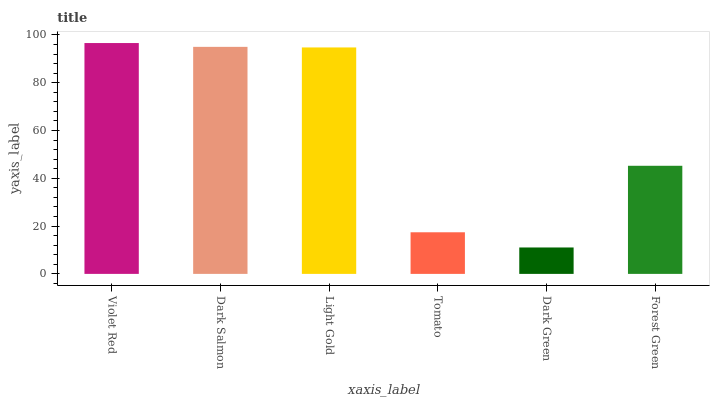Is Dark Green the minimum?
Answer yes or no. Yes. Is Violet Red the maximum?
Answer yes or no. Yes. Is Dark Salmon the minimum?
Answer yes or no. No. Is Dark Salmon the maximum?
Answer yes or no. No. Is Violet Red greater than Dark Salmon?
Answer yes or no. Yes. Is Dark Salmon less than Violet Red?
Answer yes or no. Yes. Is Dark Salmon greater than Violet Red?
Answer yes or no. No. Is Violet Red less than Dark Salmon?
Answer yes or no. No. Is Light Gold the high median?
Answer yes or no. Yes. Is Forest Green the low median?
Answer yes or no. Yes. Is Tomato the high median?
Answer yes or no. No. Is Tomato the low median?
Answer yes or no. No. 